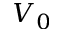Convert formula to latex. <formula><loc_0><loc_0><loc_500><loc_500>V _ { 0 }</formula> 